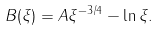Convert formula to latex. <formula><loc_0><loc_0><loc_500><loc_500>B ( \xi ) = A \xi ^ { - 3 / 4 } - \ln \xi .</formula> 